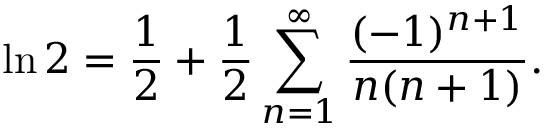<formula> <loc_0><loc_0><loc_500><loc_500>\ln 2 = { \frac { 1 } { 2 } } + { \frac { 1 } { 2 } } \sum _ { n = 1 } ^ { \infty } { \frac { ( - 1 ) ^ { n + 1 } } { n ( n + 1 ) } } .</formula> 